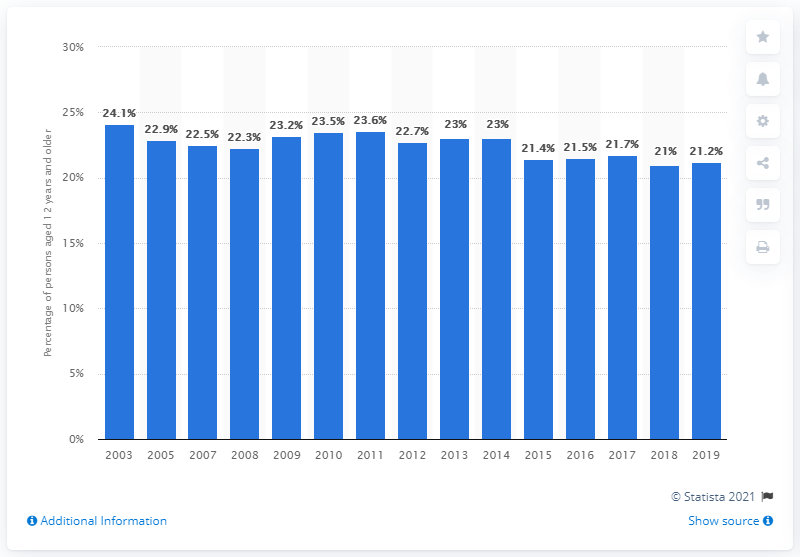Indicate a few pertinent items in this graphic. According to a survey conducted in 2019, 21.2% of Canadians reported having a high level of life stress. 